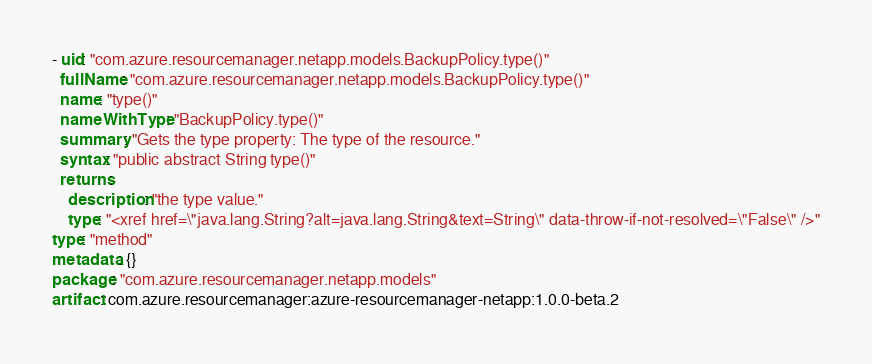<code> <loc_0><loc_0><loc_500><loc_500><_YAML_>- uid: "com.azure.resourcemanager.netapp.models.BackupPolicy.type()"
  fullName: "com.azure.resourcemanager.netapp.models.BackupPolicy.type()"
  name: "type()"
  nameWithType: "BackupPolicy.type()"
  summary: "Gets the type property: The type of the resource."
  syntax: "public abstract String type()"
  returns:
    description: "the type value."
    type: "<xref href=\"java.lang.String?alt=java.lang.String&text=String\" data-throw-if-not-resolved=\"False\" />"
type: "method"
metadata: {}
package: "com.azure.resourcemanager.netapp.models"
artifact: com.azure.resourcemanager:azure-resourcemanager-netapp:1.0.0-beta.2
</code> 